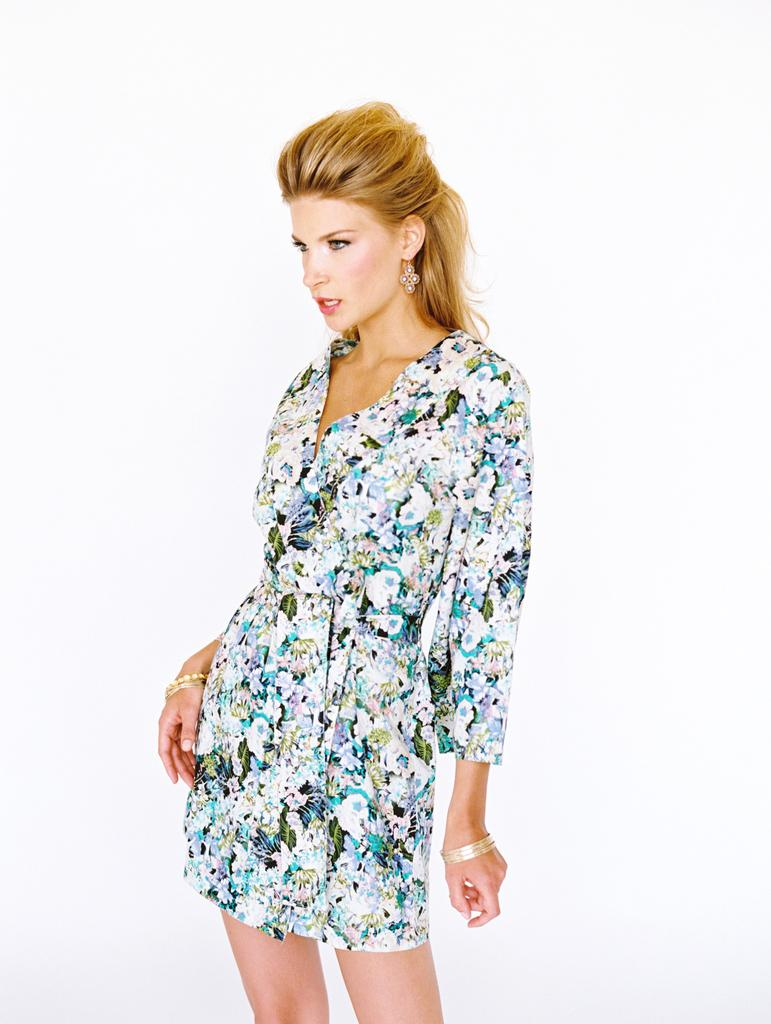Who is the main subject in the image? There is a woman in the image. What is the woman doing in the image? The woman is standing. What is the woman wearing in the image? The woman is wearing a white dress. What is the color of the woman's hair in the image? The woman has yellow hair. What can be seen behind the woman in the image? The background of the image is white. What reason does the woman give for not being a passenger in the image? The image does not mention anything about the woman being a passenger or not, so there is no reason given in the image. 